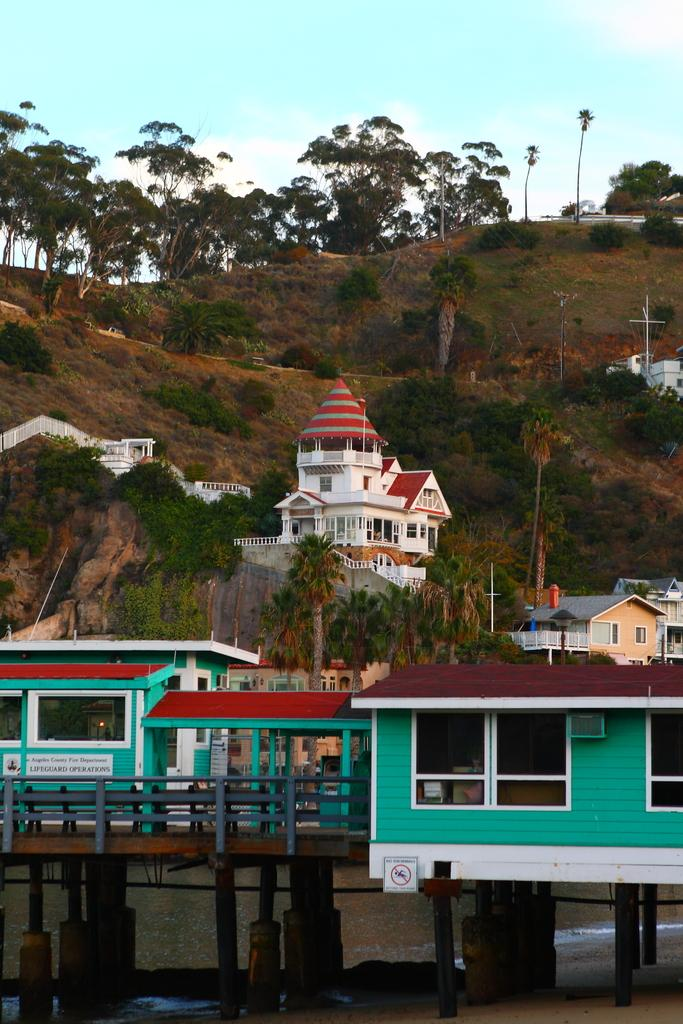What type of structures can be seen in the image? There are houses in the image. What type of natural landscape is visible in the image? There are trees on a hill in the image. What type of knee support is visible in the image? There is no knee support present in the image. What type of fuel source is being used by the houses in the image? The image does not provide information about the fuel source used by the houses. 